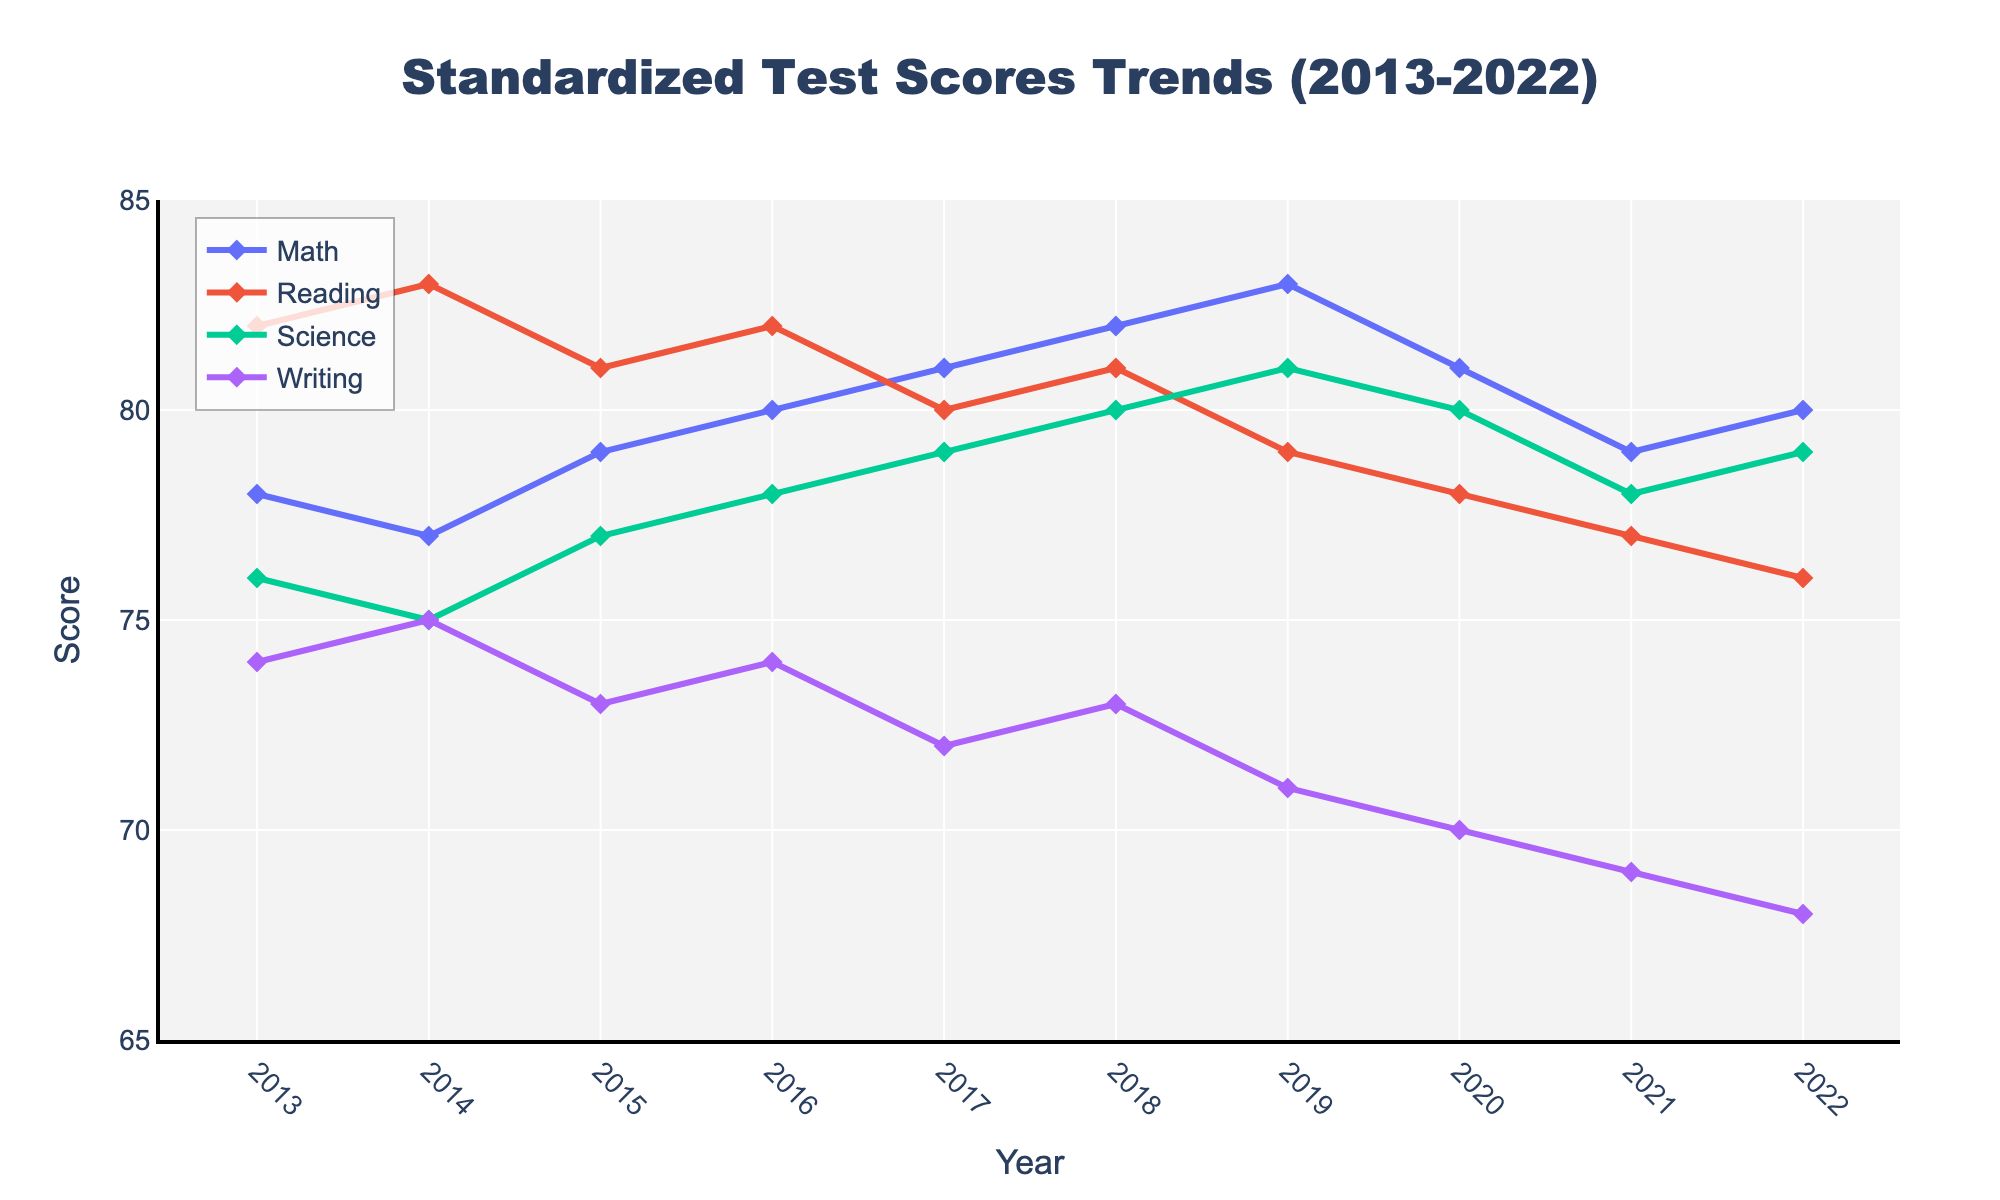What is the overall trend in Math scores from 2013 to 2022? By observing the line representing Math scores over the years, it can be noted whether the line generally moves upward or downward. In this case, the line shows an increasing trend, reaching a peak in 2019 before slightly decreasing.
Answer: Increasing trend By how many points did the Science score increase from 2013 to 2022? The Science score in 2013 was 76, and in 2022 it was 79. Subtract the initial value from the final value: 79 - 76 = 3.
Answer: 3 Which subject showed the most improvement over the decade? To determine which subject showed the most improvement, calculate the difference between the 2022 score and the 2013 score for each subject. Compare these differences. Science improved by 3 points (79-76), Reading decreased by 6 points (76-82), Math increased by 2 points (80-78), and Writing decreased by 6 points (68-74).
Answer: Science In which year did Reading scores start to consistently decline? Look at the trend line for Reading scores. The scores show a consistent downward trend starting from 2017.
Answer: 2017 What was the average score for Math over the years 2013 to 2022? Add up all the Math scores from 2013 to 2022 and divide by the number of years. (78+77+79+80+81+82+83+81+79+80) / 10 = 800 / 10 = 80.
Answer: 80 In 2020, which subject had the lowest score, and what was that score? Examine the scores represented by the markers in the year 2020. Writing had the lowest score in 2020, which was 70.
Answer: Writing, 70 Compare the Writing scores between 2013 and 2022. How much did they change? The Writing score in 2013 was 74, and in 2022 it was 68. The change is calculated as 74 - 68 = 6.
Answer: Decreased by 6 Which subject had the highest score in 2018? Look for the highest point on the graph for the year 2018. Science had the highest score of 80.
Answer: Science How do Math scores in 2014 compare to Reading scores in 2019? Identify and compare the scores for Math in 2014 (77) and Reading in 2019 (79). Reading in 2019 is higher by 2 points.
Answer: Reading in 2019 is higher What is the average decline in Writing scores per year from 2013 to 2022? First, find the total decline in Writing scores from 2013 (74) to 2022 (68), which is 74 - 68 = 6. Then divide by the number of intervals (2022-2013=9): 6/9 ≈ 0.67.
Answer: Approximately 0.67 points per year 